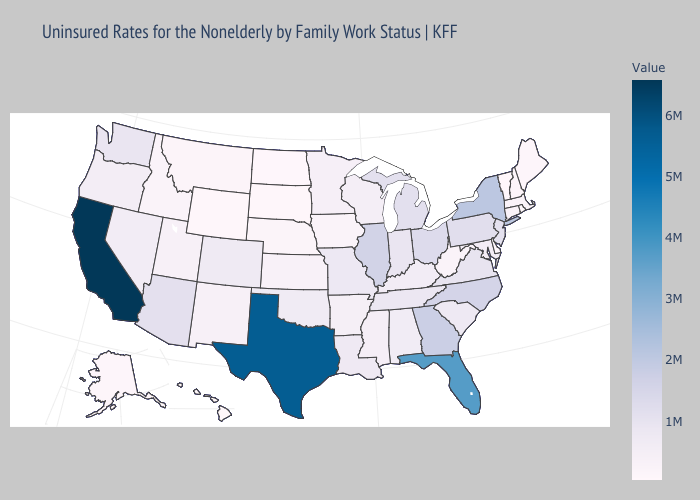Does Florida have a higher value than Texas?
Short answer required. No. Does Vermont have the lowest value in the USA?
Answer briefly. Yes. Does California have the highest value in the USA?
Answer briefly. Yes. Does the map have missing data?
Write a very short answer. No. 